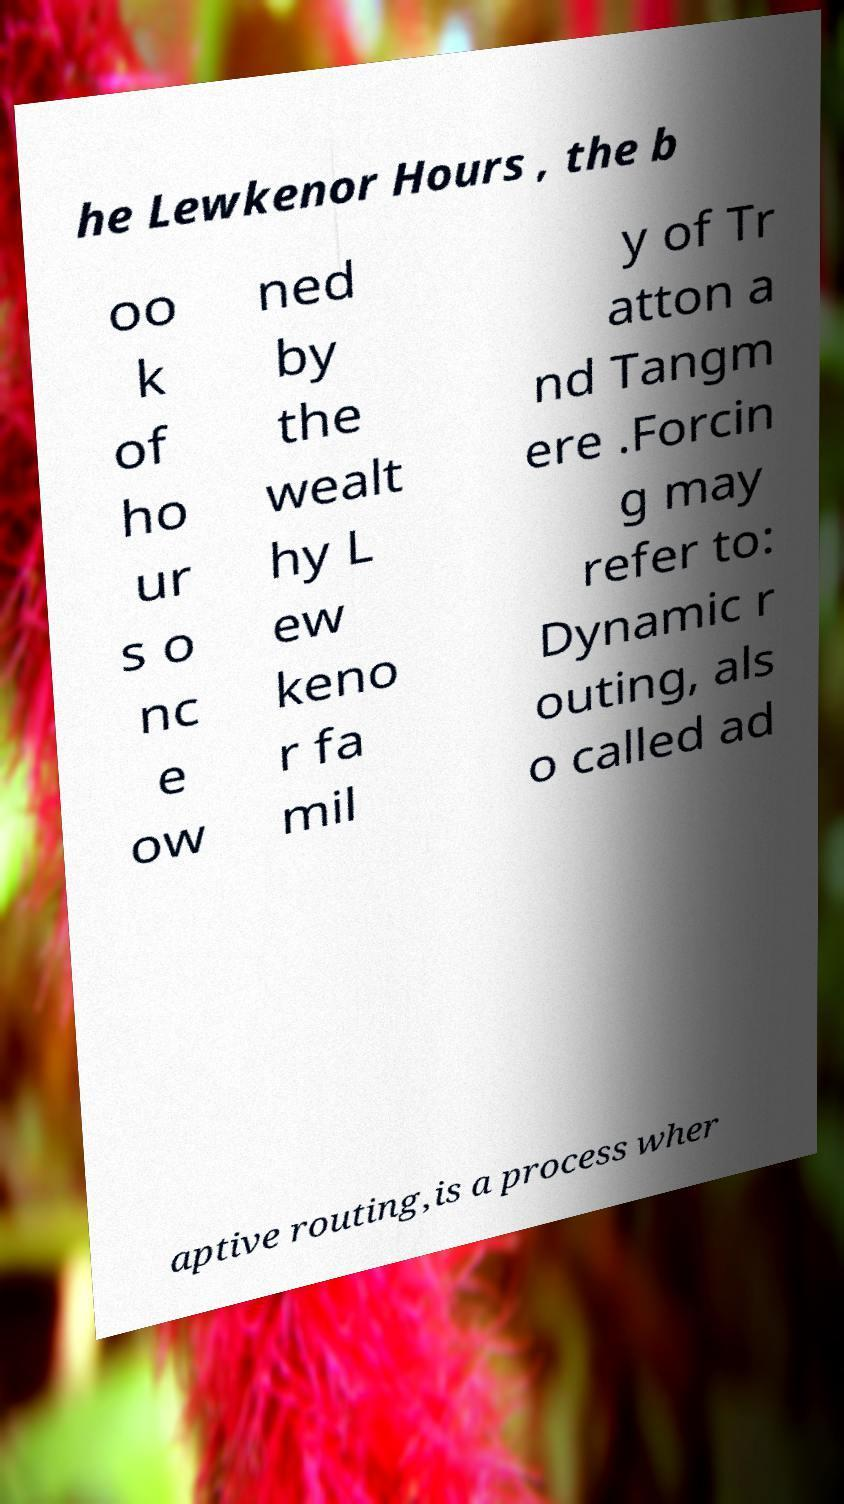For documentation purposes, I need the text within this image transcribed. Could you provide that? he Lewkenor Hours , the b oo k of ho ur s o nc e ow ned by the wealt hy L ew keno r fa mil y of Tr atton a nd Tangm ere .Forcin g may refer to: Dynamic r outing, als o called ad aptive routing,is a process wher 